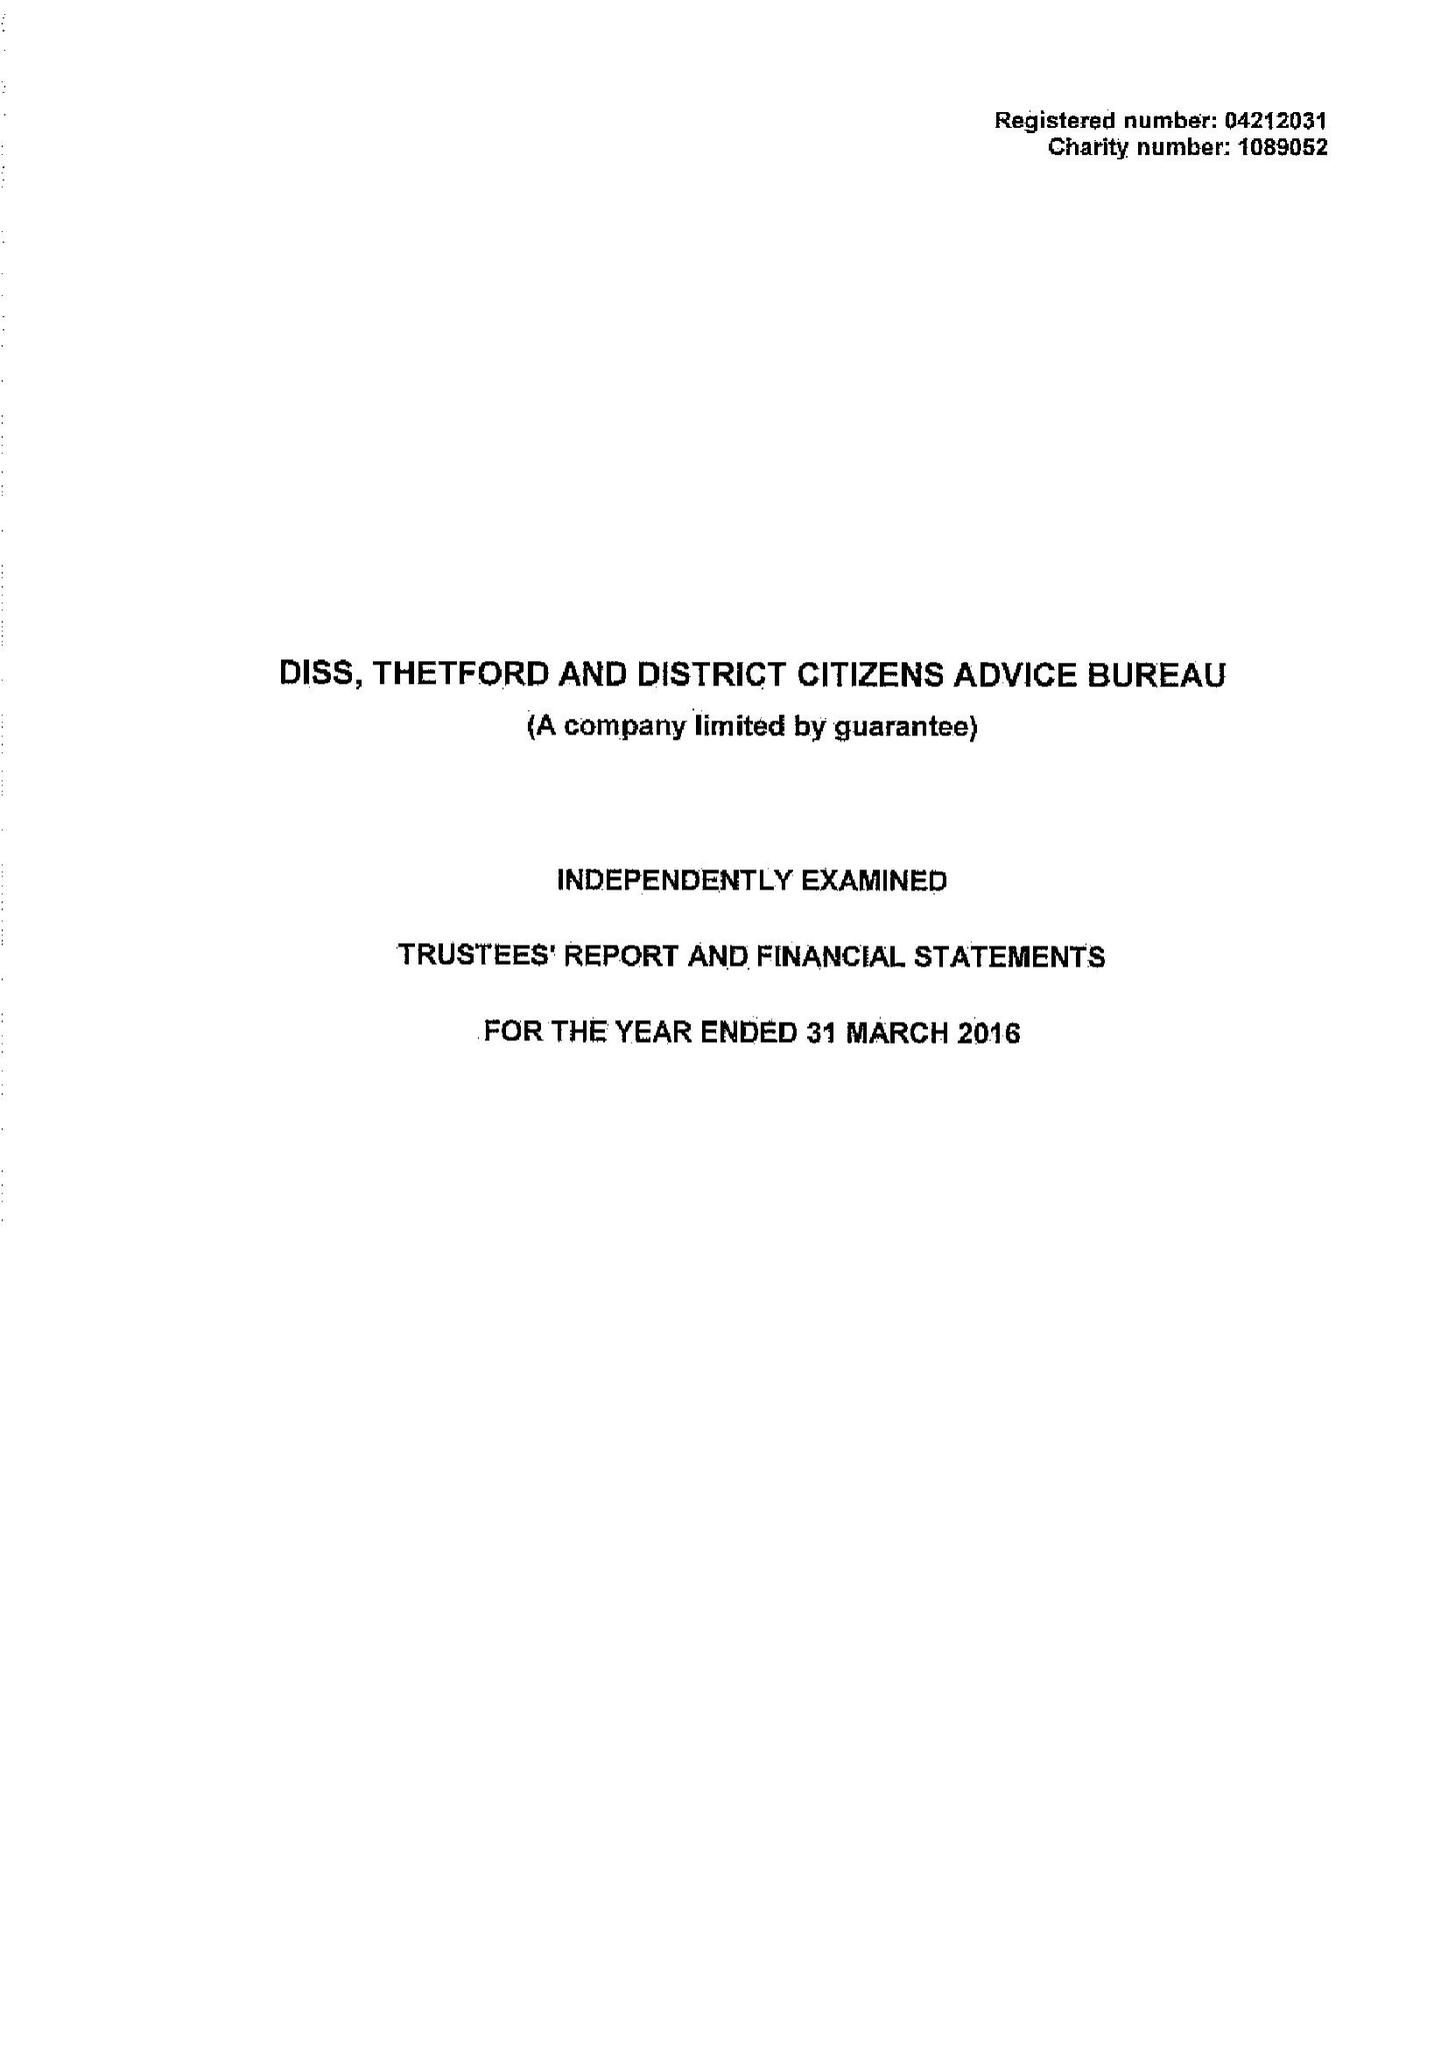What is the value for the income_annually_in_british_pounds?
Answer the question using a single word or phrase. 575885.00 